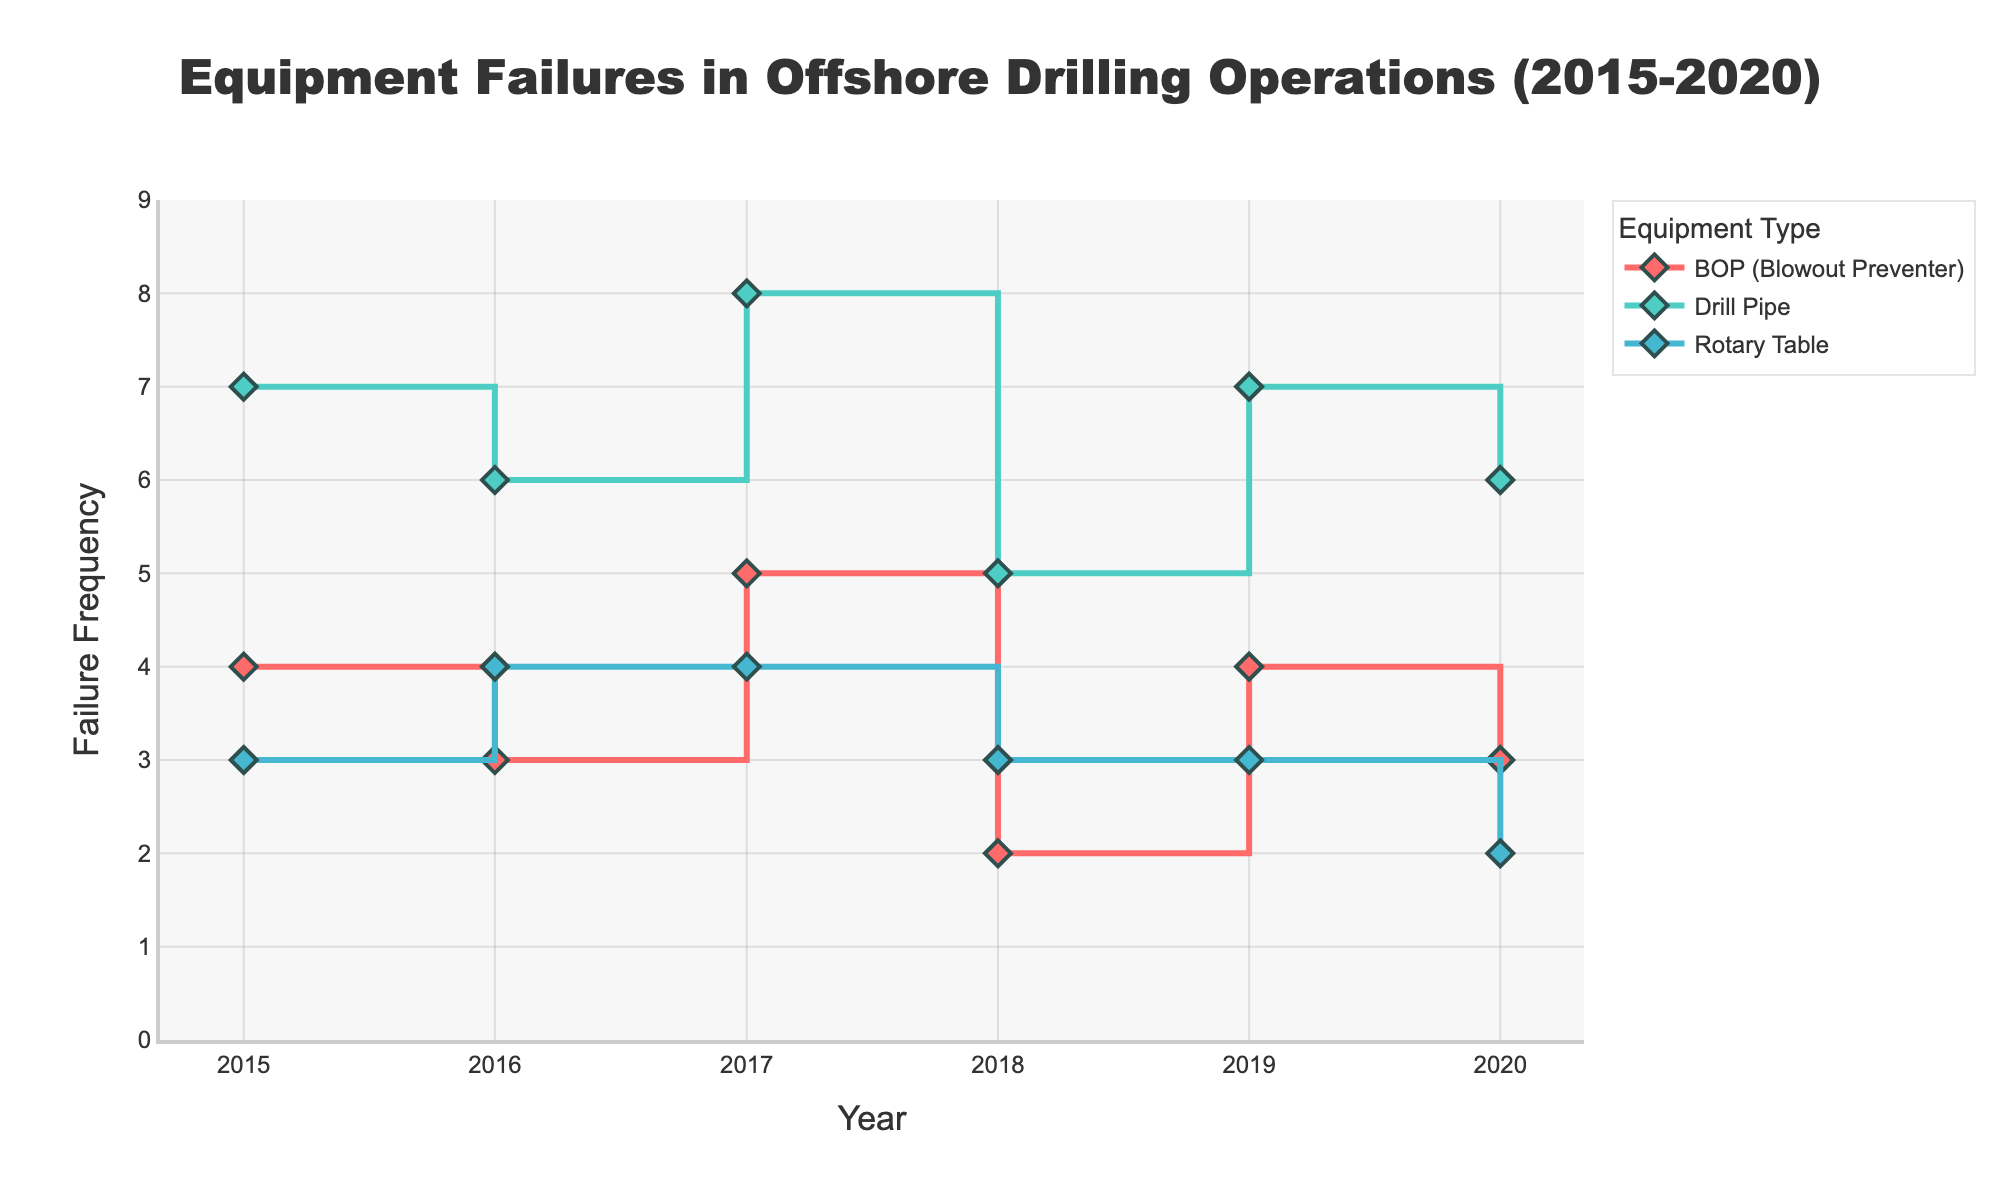What is the highest failure frequency recorded for any equipment in 2017? Look at the Frequency axis and locate the year 2017. Check all the points plotted for that year and identify the maximum frequency.
Answer: 8 Which equipment has the lowest failure frequency in 2018? Locate the year 2018 on the Year axis. Compare the plotted points for BOP, Drill Pipe, and Rotary Table; identify which one has the lowest frequency value.
Answer: Rotary Table What is the trend in BOP (Blowout Preventer) failures from 2015 to 2020? Locate the points for BOP (Blowout Preventer) across the years 2015 to 2020 and observe the changes in frequency values over these years.
Answer: Decreasing How did the failure frequency of Drill Pipe change from 2019 to 2020? Compare the frequency of Drill Pipe for the years 2019 and 2020 noted on the plot.
Answer: Decreased by 1 Which year had the highest combined frequency of failures for all equipment types? Sum up the frequencies of all equipment types for each year and identify the year with the highest total. The combined frequencies for each year are as follows: 2015 (14), 2016 (13), 2017 (17), 2018 (10), 2019 (14), 2020 (11).
Answer: 2017 How many types of equipment are displayed in the figure? Count the number of lines plus markers with distinct colors and names in the legend/title section of the plot.
Answer: 3 What is the average failure frequency of the Rotary Table over the years 2015 to 2020? Add up the frequencies of Rotary Table from 2015 to 2020 and divide by the number of years: (3 + 4 + 4 + 3 + 3 + 2) / 6.
Answer: 3 How does the failure frequency of BOP (Blowout Preventer) in 2016 compare to its frequency in 2015? Subtract the frequency of BOP in 2015 from its frequency in 2016: 3 - 4.
Answer: Decreased by 1 Which equipment type demonstrated the most consistent failure frequency over the given years? Examine the fluctuation in frequency for each equipment type over the years and identify the one with the least variation.
Answer: Rotary Table 